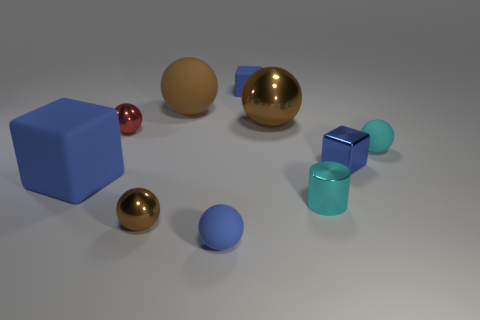Subtract all purple cylinders. How many brown balls are left? 3 Subtract 3 balls. How many balls are left? 3 Subtract all large brown shiny spheres. How many spheres are left? 5 Subtract all blue spheres. How many spheres are left? 5 Subtract all purple balls. Subtract all gray cubes. How many balls are left? 6 Subtract all cylinders. How many objects are left? 9 Subtract all small blue metallic objects. Subtract all large cubes. How many objects are left? 8 Add 3 tiny metal spheres. How many tiny metal spheres are left? 5 Add 2 large shiny spheres. How many large shiny spheres exist? 3 Subtract 3 brown spheres. How many objects are left? 7 